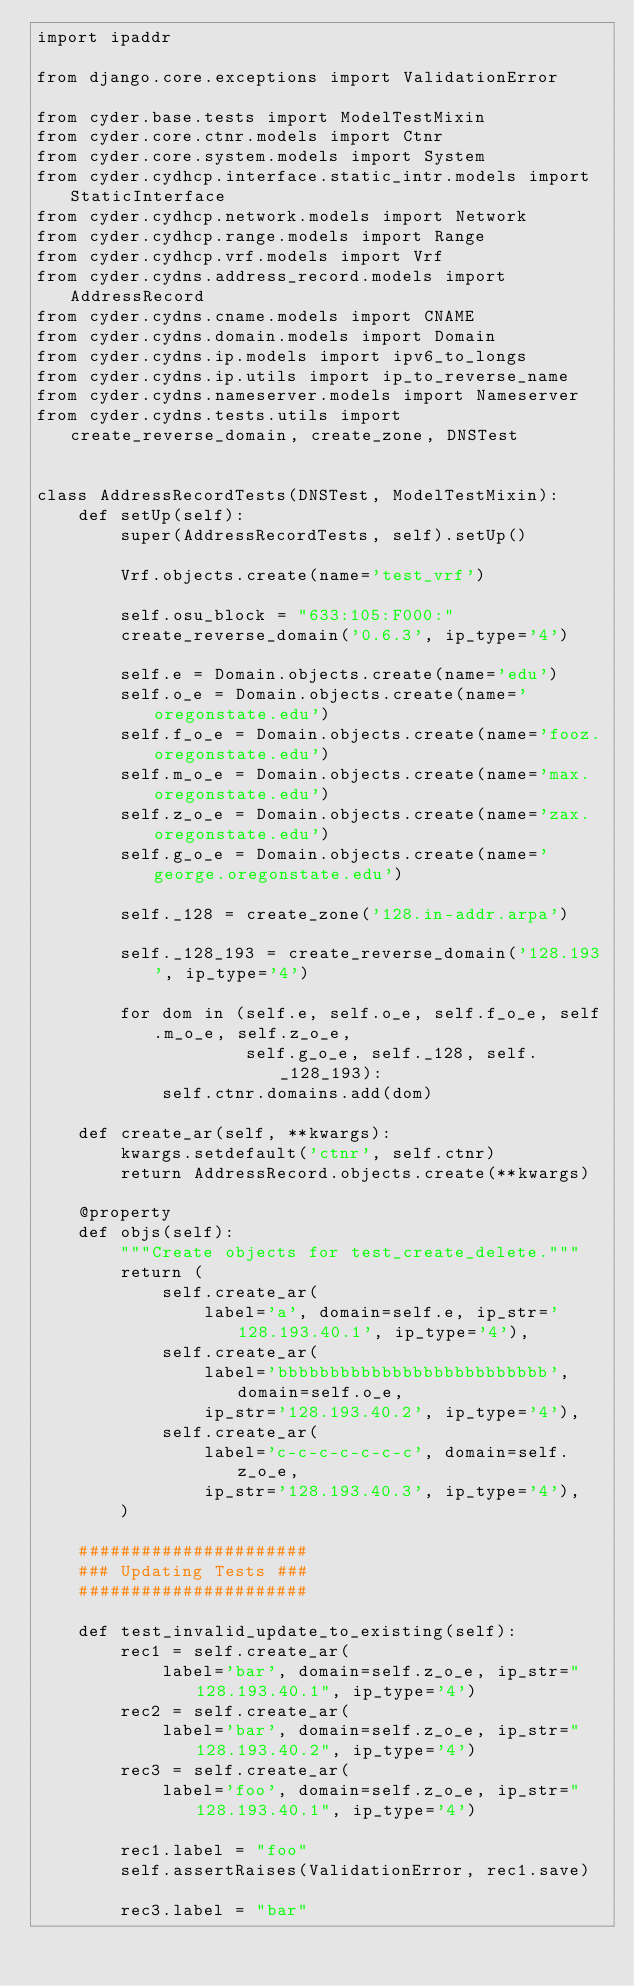Convert code to text. <code><loc_0><loc_0><loc_500><loc_500><_Python_>import ipaddr

from django.core.exceptions import ValidationError

from cyder.base.tests import ModelTestMixin
from cyder.core.ctnr.models import Ctnr
from cyder.core.system.models import System
from cyder.cydhcp.interface.static_intr.models import StaticInterface
from cyder.cydhcp.network.models import Network
from cyder.cydhcp.range.models import Range
from cyder.cydhcp.vrf.models import Vrf
from cyder.cydns.address_record.models import AddressRecord
from cyder.cydns.cname.models import CNAME
from cyder.cydns.domain.models import Domain
from cyder.cydns.ip.models import ipv6_to_longs
from cyder.cydns.ip.utils import ip_to_reverse_name
from cyder.cydns.nameserver.models import Nameserver
from cyder.cydns.tests.utils import create_reverse_domain, create_zone, DNSTest


class AddressRecordTests(DNSTest, ModelTestMixin):
    def setUp(self):
        super(AddressRecordTests, self).setUp()

        Vrf.objects.create(name='test_vrf')

        self.osu_block = "633:105:F000:"
        create_reverse_domain('0.6.3', ip_type='4')

        self.e = Domain.objects.create(name='edu')
        self.o_e = Domain.objects.create(name='oregonstate.edu')
        self.f_o_e = Domain.objects.create(name='fooz.oregonstate.edu')
        self.m_o_e = Domain.objects.create(name='max.oregonstate.edu')
        self.z_o_e = Domain.objects.create(name='zax.oregonstate.edu')
        self.g_o_e = Domain.objects.create(name='george.oregonstate.edu')

        self._128 = create_zone('128.in-addr.arpa')

        self._128_193 = create_reverse_domain('128.193', ip_type='4')

        for dom in (self.e, self.o_e, self.f_o_e, self.m_o_e, self.z_o_e,
                    self.g_o_e, self._128, self._128_193):
            self.ctnr.domains.add(dom)

    def create_ar(self, **kwargs):
        kwargs.setdefault('ctnr', self.ctnr)
        return AddressRecord.objects.create(**kwargs)

    @property
    def objs(self):
        """Create objects for test_create_delete."""
        return (
            self.create_ar(
                label='a', domain=self.e, ip_str='128.193.40.1', ip_type='4'),
            self.create_ar(
                label='bbbbbbbbbbbbbbbbbbbbbbbbbb', domain=self.o_e,
                ip_str='128.193.40.2', ip_type='4'),
            self.create_ar(
                label='c-c-c-c-c-c-c', domain=self.z_o_e,
                ip_str='128.193.40.3', ip_type='4'),
        )

    ######################
    ### Updating Tests ###
    ######################

    def test_invalid_update_to_existing(self):
        rec1 = self.create_ar(
            label='bar', domain=self.z_o_e, ip_str="128.193.40.1", ip_type='4')
        rec2 = self.create_ar(
            label='bar', domain=self.z_o_e, ip_str="128.193.40.2", ip_type='4')
        rec3 = self.create_ar(
            label='foo', domain=self.z_o_e, ip_str="128.193.40.1", ip_type='4')

        rec1.label = "foo"
        self.assertRaises(ValidationError, rec1.save)

        rec3.label = "bar"</code> 